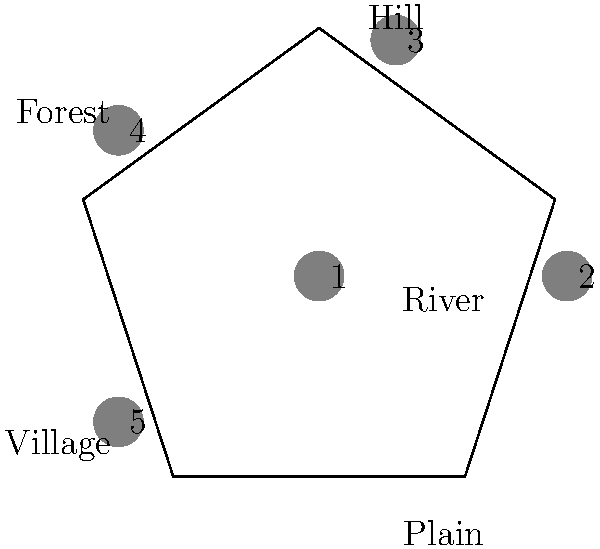In recreating the Battle of Five Corners, a pivotal moment in our nation's history, you must arrange five historical artifacts on the battlefield. The artifacts represent: 1) The General's sword, 2) A cannon, 3) A cavalry helmet, 4) A tattered flag, and 5) A soldier's diary. Given that the cavalry charged from the hill, the artillery was positioned by the river, the infantry held the forest, the flag was raised in the village, and the General led from the plain, how should the artifacts be arranged? To solve this puzzle, we need to match each artifact with its corresponding location based on the historical context provided:

1. The General's sword (1): The General led from the plain, so this artifact should be placed at position 5.
2. A cannon (2): The artillery was positioned by the river, so this artifact should be placed at position 1.
3. A cavalry helmet (3): The cavalry charged from the hill, so this artifact should be placed at position 2.
4. A tattered flag (4): The flag was raised in the village, so this artifact should be placed at position 4.
5. A soldier's diary (5): By process of elimination, the infantry held the forest, so this artifact should be placed at position 3.

The correct arrangement, listing the artifact numbers in order of their positions on the battlefield (clockwise from the river), is: 2, 3, 5, 4, 1.
Answer: 2, 3, 5, 4, 1 